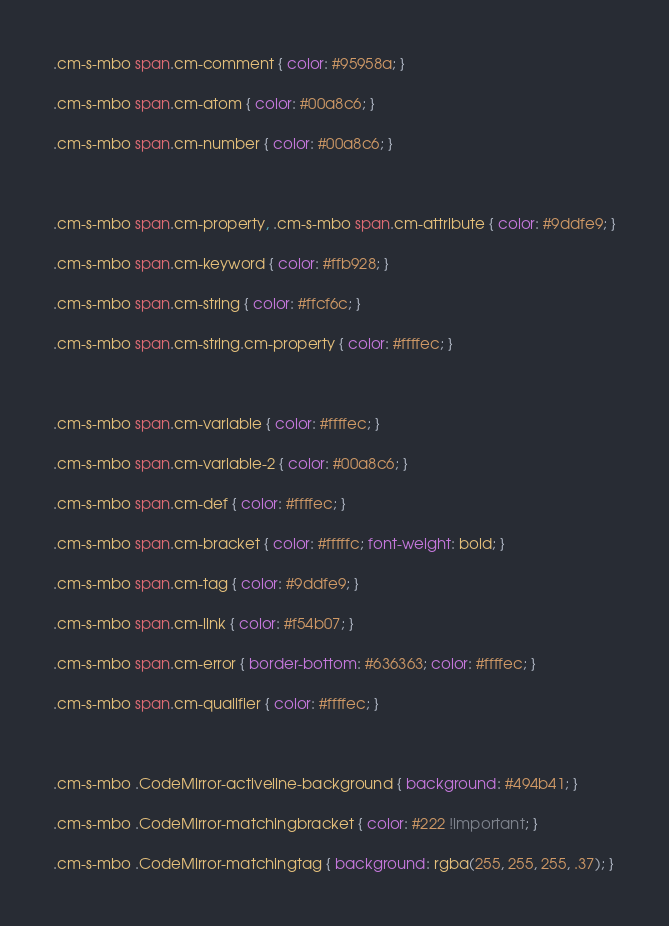Convert code to text. <code><loc_0><loc_0><loc_500><loc_500><_CSS_>.cm-s-mbo span.cm-comment { color: #95958a; }
.cm-s-mbo span.cm-atom { color: #00a8c6; }
.cm-s-mbo span.cm-number { color: #00a8c6; }

.cm-s-mbo span.cm-property, .cm-s-mbo span.cm-attribute { color: #9ddfe9; }
.cm-s-mbo span.cm-keyword { color: #ffb928; }
.cm-s-mbo span.cm-string { color: #ffcf6c; }
.cm-s-mbo span.cm-string.cm-property { color: #ffffec; }

.cm-s-mbo span.cm-variable { color: #ffffec; }
.cm-s-mbo span.cm-variable-2 { color: #00a8c6; }
.cm-s-mbo span.cm-def { color: #ffffec; }
.cm-s-mbo span.cm-bracket { color: #fffffc; font-weight: bold; }
.cm-s-mbo span.cm-tag { color: #9ddfe9; }
.cm-s-mbo span.cm-link { color: #f54b07; }
.cm-s-mbo span.cm-error { border-bottom: #636363; color: #ffffec; }
.cm-s-mbo span.cm-qualifier { color: #ffffec; }

.cm-s-mbo .CodeMirror-activeline-background { background: #494b41; }
.cm-s-mbo .CodeMirror-matchingbracket { color: #222 !important; }
.cm-s-mbo .CodeMirror-matchingtag { background: rgba(255, 255, 255, .37); }
</code> 